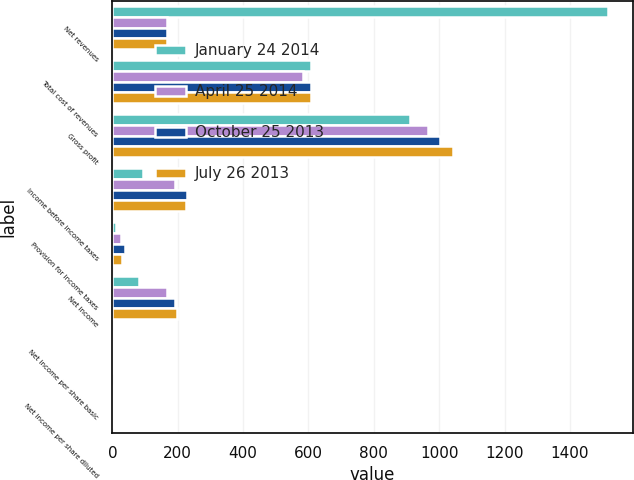Convert chart to OTSL. <chart><loc_0><loc_0><loc_500><loc_500><stacked_bar_chart><ecel><fcel>Net revenues<fcel>Total cost of revenues<fcel>Gross profit<fcel>Income before income taxes<fcel>Provision for income taxes<fcel>Net income<fcel>Net income per share basic<fcel>Net income per share diluted<nl><fcel>January 24 2014<fcel>1516.2<fcel>606.6<fcel>909.6<fcel>92.3<fcel>10.7<fcel>81.6<fcel>0.23<fcel>0.23<nl><fcel>April 25 2014<fcel>166.8<fcel>584.7<fcel>965.2<fcel>192.2<fcel>25.4<fcel>166.8<fcel>0.49<fcel>0.48<nl><fcel>October 25 2013<fcel>166.8<fcel>607.7<fcel>1002.3<fcel>229.6<fcel>37.5<fcel>192.1<fcel>0.57<fcel>0.55<nl><fcel>July 26 2013<fcel>166.8<fcel>607<fcel>1042<fcel>226.6<fcel>29.6<fcel>197<fcel>0.6<fcel>0.59<nl></chart> 